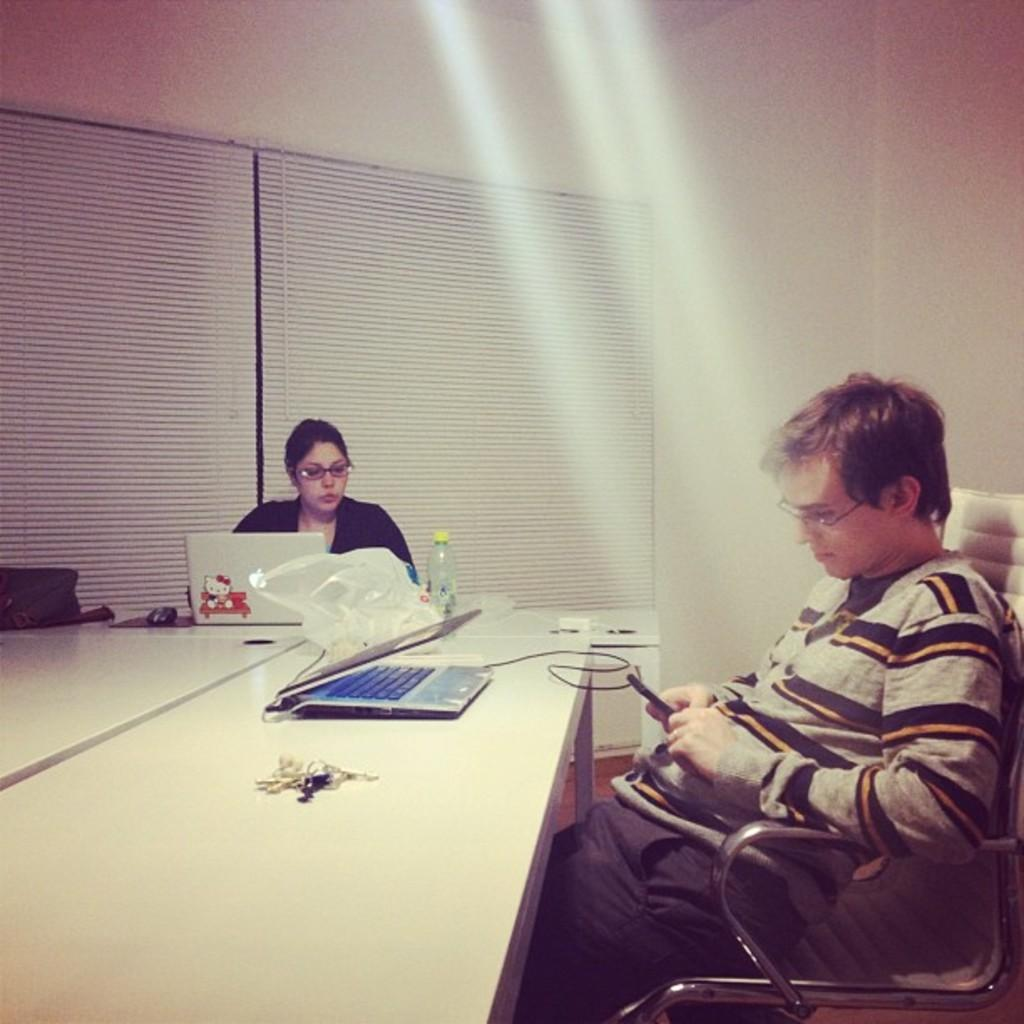Who is present in the image? There is a man and a woman in the image. What are the man and woman doing in the image? Both the man and woman are sitting on chairs. What is on the table in the image? There are laptops and a bottle on the table. What can be seen in the background of the image? There is a wall in the background of the image. How many beds are visible in the image? There are no beds present in the image. What type of business is being conducted in the image? There is no indication of a business being conducted in the image. 